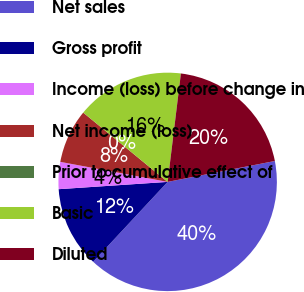Convert chart. <chart><loc_0><loc_0><loc_500><loc_500><pie_chart><fcel>Net sales<fcel>Gross profit<fcel>Income (loss) before change in<fcel>Net income (loss)<fcel>Prior to cumulative effect of<fcel>Basic<fcel>Diluted<nl><fcel>40.0%<fcel>12.0%<fcel>4.0%<fcel>8.0%<fcel>0.0%<fcel>16.0%<fcel>20.0%<nl></chart> 